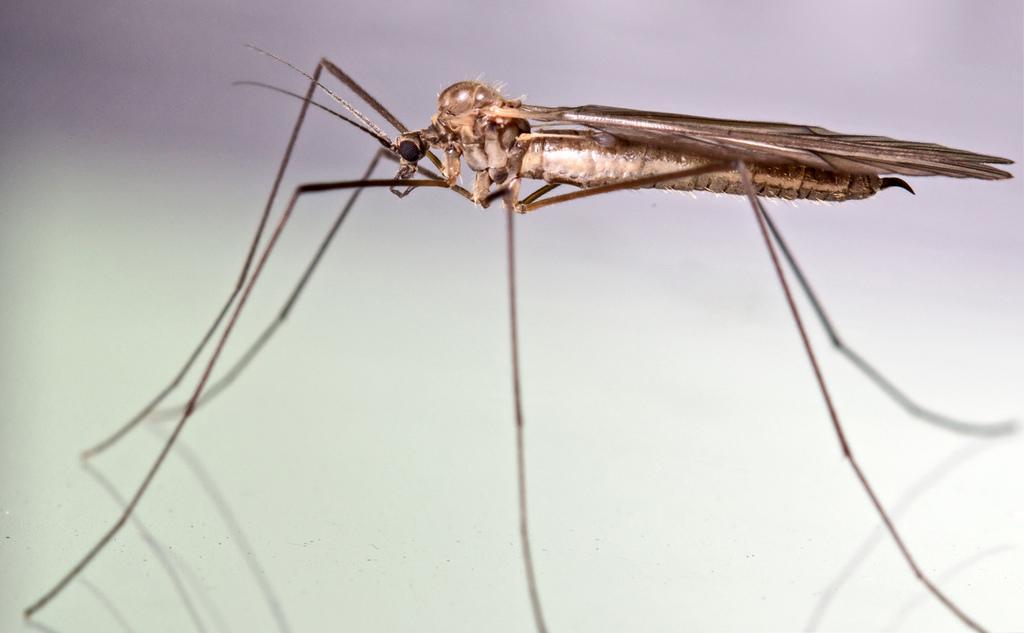In one or two sentences, can you explain what this image depicts? There is a mosquito on a white surface. 